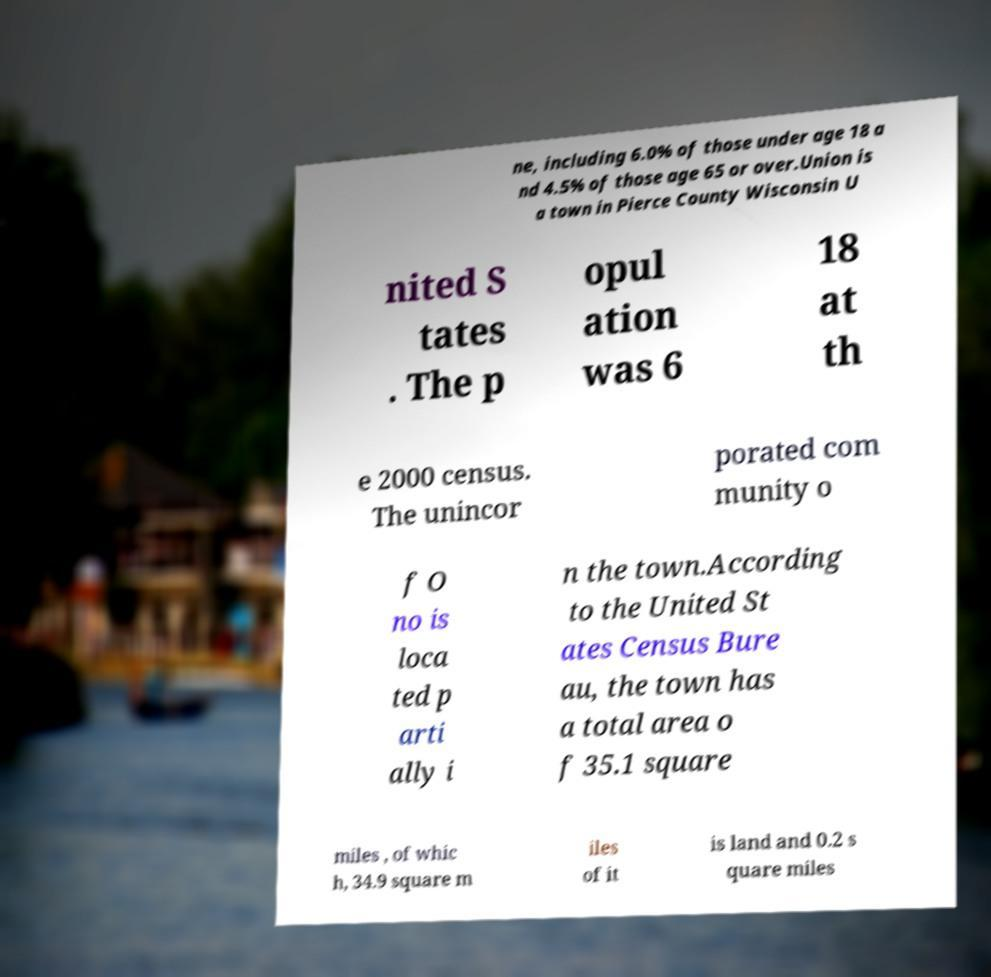Could you extract and type out the text from this image? ne, including 6.0% of those under age 18 a nd 4.5% of those age 65 or over.Union is a town in Pierce County Wisconsin U nited S tates . The p opul ation was 6 18 at th e 2000 census. The unincor porated com munity o f O no is loca ted p arti ally i n the town.According to the United St ates Census Bure au, the town has a total area o f 35.1 square miles , of whic h, 34.9 square m iles of it is land and 0.2 s quare miles 